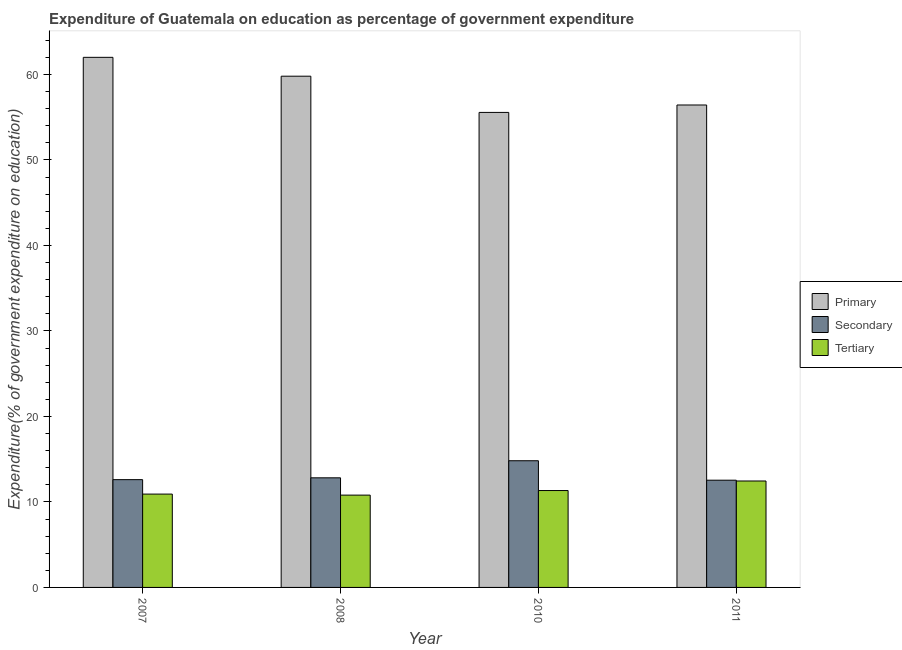How many different coloured bars are there?
Make the answer very short. 3. How many groups of bars are there?
Your answer should be compact. 4. How many bars are there on the 2nd tick from the right?
Keep it short and to the point. 3. What is the label of the 2nd group of bars from the left?
Your answer should be compact. 2008. In how many cases, is the number of bars for a given year not equal to the number of legend labels?
Your response must be concise. 0. What is the expenditure on secondary education in 2011?
Make the answer very short. 12.54. Across all years, what is the maximum expenditure on secondary education?
Give a very brief answer. 14.82. Across all years, what is the minimum expenditure on secondary education?
Offer a terse response. 12.54. In which year was the expenditure on secondary education minimum?
Your response must be concise. 2011. What is the total expenditure on primary education in the graph?
Ensure brevity in your answer.  233.76. What is the difference between the expenditure on tertiary education in 2008 and that in 2010?
Give a very brief answer. -0.54. What is the difference between the expenditure on secondary education in 2011 and the expenditure on tertiary education in 2008?
Offer a terse response. -0.28. What is the average expenditure on secondary education per year?
Make the answer very short. 13.2. What is the ratio of the expenditure on secondary education in 2007 to that in 2008?
Your answer should be very brief. 0.98. Is the expenditure on primary education in 2007 less than that in 2008?
Offer a terse response. No. Is the difference between the expenditure on primary education in 2007 and 2008 greater than the difference between the expenditure on tertiary education in 2007 and 2008?
Offer a very short reply. No. What is the difference between the highest and the second highest expenditure on primary education?
Ensure brevity in your answer.  2.21. What is the difference between the highest and the lowest expenditure on tertiary education?
Ensure brevity in your answer.  1.65. In how many years, is the expenditure on primary education greater than the average expenditure on primary education taken over all years?
Ensure brevity in your answer.  2. Is the sum of the expenditure on primary education in 2008 and 2011 greater than the maximum expenditure on secondary education across all years?
Provide a succinct answer. Yes. What does the 1st bar from the left in 2010 represents?
Your answer should be very brief. Primary. What does the 1st bar from the right in 2011 represents?
Provide a short and direct response. Tertiary. How many years are there in the graph?
Your answer should be compact. 4. What is the difference between two consecutive major ticks on the Y-axis?
Provide a succinct answer. 10. Does the graph contain grids?
Your answer should be very brief. No. What is the title of the graph?
Keep it short and to the point. Expenditure of Guatemala on education as percentage of government expenditure. Does "ICT services" appear as one of the legend labels in the graph?
Your answer should be compact. No. What is the label or title of the X-axis?
Ensure brevity in your answer.  Year. What is the label or title of the Y-axis?
Offer a very short reply. Expenditure(% of government expenditure on education). What is the Expenditure(% of government expenditure on education) of Primary in 2007?
Provide a short and direct response. 62. What is the Expenditure(% of government expenditure on education) in Secondary in 2007?
Ensure brevity in your answer.  12.6. What is the Expenditure(% of government expenditure on education) in Tertiary in 2007?
Offer a terse response. 10.92. What is the Expenditure(% of government expenditure on education) in Primary in 2008?
Give a very brief answer. 59.79. What is the Expenditure(% of government expenditure on education) of Secondary in 2008?
Ensure brevity in your answer.  12.82. What is the Expenditure(% of government expenditure on education) of Tertiary in 2008?
Give a very brief answer. 10.8. What is the Expenditure(% of government expenditure on education) in Primary in 2010?
Provide a succinct answer. 55.55. What is the Expenditure(% of government expenditure on education) of Secondary in 2010?
Provide a short and direct response. 14.82. What is the Expenditure(% of government expenditure on education) of Tertiary in 2010?
Your answer should be compact. 11.33. What is the Expenditure(% of government expenditure on education) of Primary in 2011?
Offer a very short reply. 56.42. What is the Expenditure(% of government expenditure on education) of Secondary in 2011?
Give a very brief answer. 12.54. What is the Expenditure(% of government expenditure on education) of Tertiary in 2011?
Offer a terse response. 12.45. Across all years, what is the maximum Expenditure(% of government expenditure on education) of Primary?
Your answer should be very brief. 62. Across all years, what is the maximum Expenditure(% of government expenditure on education) of Secondary?
Your answer should be compact. 14.82. Across all years, what is the maximum Expenditure(% of government expenditure on education) of Tertiary?
Offer a very short reply. 12.45. Across all years, what is the minimum Expenditure(% of government expenditure on education) in Primary?
Provide a succinct answer. 55.55. Across all years, what is the minimum Expenditure(% of government expenditure on education) in Secondary?
Give a very brief answer. 12.54. Across all years, what is the minimum Expenditure(% of government expenditure on education) in Tertiary?
Your response must be concise. 10.8. What is the total Expenditure(% of government expenditure on education) of Primary in the graph?
Your response must be concise. 233.76. What is the total Expenditure(% of government expenditure on education) of Secondary in the graph?
Offer a very short reply. 52.78. What is the total Expenditure(% of government expenditure on education) in Tertiary in the graph?
Ensure brevity in your answer.  45.49. What is the difference between the Expenditure(% of government expenditure on education) in Primary in 2007 and that in 2008?
Ensure brevity in your answer.  2.21. What is the difference between the Expenditure(% of government expenditure on education) of Secondary in 2007 and that in 2008?
Your answer should be compact. -0.21. What is the difference between the Expenditure(% of government expenditure on education) in Tertiary in 2007 and that in 2008?
Offer a very short reply. 0.12. What is the difference between the Expenditure(% of government expenditure on education) of Primary in 2007 and that in 2010?
Offer a very short reply. 6.44. What is the difference between the Expenditure(% of government expenditure on education) in Secondary in 2007 and that in 2010?
Provide a succinct answer. -2.21. What is the difference between the Expenditure(% of government expenditure on education) in Tertiary in 2007 and that in 2010?
Give a very brief answer. -0.42. What is the difference between the Expenditure(% of government expenditure on education) in Primary in 2007 and that in 2011?
Make the answer very short. 5.57. What is the difference between the Expenditure(% of government expenditure on education) in Secondary in 2007 and that in 2011?
Your answer should be compact. 0.06. What is the difference between the Expenditure(% of government expenditure on education) in Tertiary in 2007 and that in 2011?
Provide a short and direct response. -1.53. What is the difference between the Expenditure(% of government expenditure on education) in Primary in 2008 and that in 2010?
Offer a terse response. 4.24. What is the difference between the Expenditure(% of government expenditure on education) of Secondary in 2008 and that in 2010?
Provide a succinct answer. -2. What is the difference between the Expenditure(% of government expenditure on education) in Tertiary in 2008 and that in 2010?
Offer a very short reply. -0.54. What is the difference between the Expenditure(% of government expenditure on education) of Primary in 2008 and that in 2011?
Offer a terse response. 3.37. What is the difference between the Expenditure(% of government expenditure on education) of Secondary in 2008 and that in 2011?
Your answer should be compact. 0.28. What is the difference between the Expenditure(% of government expenditure on education) in Tertiary in 2008 and that in 2011?
Offer a terse response. -1.65. What is the difference between the Expenditure(% of government expenditure on education) of Primary in 2010 and that in 2011?
Provide a short and direct response. -0.87. What is the difference between the Expenditure(% of government expenditure on education) in Secondary in 2010 and that in 2011?
Your response must be concise. 2.27. What is the difference between the Expenditure(% of government expenditure on education) of Tertiary in 2010 and that in 2011?
Your response must be concise. -1.12. What is the difference between the Expenditure(% of government expenditure on education) of Primary in 2007 and the Expenditure(% of government expenditure on education) of Secondary in 2008?
Your answer should be compact. 49.18. What is the difference between the Expenditure(% of government expenditure on education) of Primary in 2007 and the Expenditure(% of government expenditure on education) of Tertiary in 2008?
Keep it short and to the point. 51.2. What is the difference between the Expenditure(% of government expenditure on education) of Secondary in 2007 and the Expenditure(% of government expenditure on education) of Tertiary in 2008?
Make the answer very short. 1.81. What is the difference between the Expenditure(% of government expenditure on education) in Primary in 2007 and the Expenditure(% of government expenditure on education) in Secondary in 2010?
Keep it short and to the point. 47.18. What is the difference between the Expenditure(% of government expenditure on education) in Primary in 2007 and the Expenditure(% of government expenditure on education) in Tertiary in 2010?
Provide a succinct answer. 50.66. What is the difference between the Expenditure(% of government expenditure on education) of Secondary in 2007 and the Expenditure(% of government expenditure on education) of Tertiary in 2010?
Your answer should be compact. 1.27. What is the difference between the Expenditure(% of government expenditure on education) in Primary in 2007 and the Expenditure(% of government expenditure on education) in Secondary in 2011?
Your answer should be compact. 49.45. What is the difference between the Expenditure(% of government expenditure on education) of Primary in 2007 and the Expenditure(% of government expenditure on education) of Tertiary in 2011?
Provide a succinct answer. 49.55. What is the difference between the Expenditure(% of government expenditure on education) of Secondary in 2007 and the Expenditure(% of government expenditure on education) of Tertiary in 2011?
Your answer should be very brief. 0.16. What is the difference between the Expenditure(% of government expenditure on education) in Primary in 2008 and the Expenditure(% of government expenditure on education) in Secondary in 2010?
Make the answer very short. 44.97. What is the difference between the Expenditure(% of government expenditure on education) in Primary in 2008 and the Expenditure(% of government expenditure on education) in Tertiary in 2010?
Keep it short and to the point. 48.46. What is the difference between the Expenditure(% of government expenditure on education) in Secondary in 2008 and the Expenditure(% of government expenditure on education) in Tertiary in 2010?
Give a very brief answer. 1.49. What is the difference between the Expenditure(% of government expenditure on education) in Primary in 2008 and the Expenditure(% of government expenditure on education) in Secondary in 2011?
Provide a succinct answer. 47.25. What is the difference between the Expenditure(% of government expenditure on education) in Primary in 2008 and the Expenditure(% of government expenditure on education) in Tertiary in 2011?
Offer a very short reply. 47.34. What is the difference between the Expenditure(% of government expenditure on education) in Secondary in 2008 and the Expenditure(% of government expenditure on education) in Tertiary in 2011?
Ensure brevity in your answer.  0.37. What is the difference between the Expenditure(% of government expenditure on education) in Primary in 2010 and the Expenditure(% of government expenditure on education) in Secondary in 2011?
Provide a succinct answer. 43.01. What is the difference between the Expenditure(% of government expenditure on education) of Primary in 2010 and the Expenditure(% of government expenditure on education) of Tertiary in 2011?
Ensure brevity in your answer.  43.11. What is the difference between the Expenditure(% of government expenditure on education) of Secondary in 2010 and the Expenditure(% of government expenditure on education) of Tertiary in 2011?
Your response must be concise. 2.37. What is the average Expenditure(% of government expenditure on education) of Primary per year?
Keep it short and to the point. 58.44. What is the average Expenditure(% of government expenditure on education) in Secondary per year?
Ensure brevity in your answer.  13.2. What is the average Expenditure(% of government expenditure on education) of Tertiary per year?
Offer a very short reply. 11.37. In the year 2007, what is the difference between the Expenditure(% of government expenditure on education) in Primary and Expenditure(% of government expenditure on education) in Secondary?
Give a very brief answer. 49.39. In the year 2007, what is the difference between the Expenditure(% of government expenditure on education) in Primary and Expenditure(% of government expenditure on education) in Tertiary?
Provide a short and direct response. 51.08. In the year 2007, what is the difference between the Expenditure(% of government expenditure on education) in Secondary and Expenditure(% of government expenditure on education) in Tertiary?
Offer a terse response. 1.69. In the year 2008, what is the difference between the Expenditure(% of government expenditure on education) in Primary and Expenditure(% of government expenditure on education) in Secondary?
Provide a short and direct response. 46.97. In the year 2008, what is the difference between the Expenditure(% of government expenditure on education) in Primary and Expenditure(% of government expenditure on education) in Tertiary?
Your response must be concise. 48.99. In the year 2008, what is the difference between the Expenditure(% of government expenditure on education) of Secondary and Expenditure(% of government expenditure on education) of Tertiary?
Provide a succinct answer. 2.02. In the year 2010, what is the difference between the Expenditure(% of government expenditure on education) of Primary and Expenditure(% of government expenditure on education) of Secondary?
Offer a very short reply. 40.74. In the year 2010, what is the difference between the Expenditure(% of government expenditure on education) of Primary and Expenditure(% of government expenditure on education) of Tertiary?
Offer a very short reply. 44.22. In the year 2010, what is the difference between the Expenditure(% of government expenditure on education) in Secondary and Expenditure(% of government expenditure on education) in Tertiary?
Offer a terse response. 3.48. In the year 2011, what is the difference between the Expenditure(% of government expenditure on education) of Primary and Expenditure(% of government expenditure on education) of Secondary?
Your answer should be very brief. 43.88. In the year 2011, what is the difference between the Expenditure(% of government expenditure on education) in Primary and Expenditure(% of government expenditure on education) in Tertiary?
Your answer should be very brief. 43.97. In the year 2011, what is the difference between the Expenditure(% of government expenditure on education) in Secondary and Expenditure(% of government expenditure on education) in Tertiary?
Your answer should be compact. 0.09. What is the ratio of the Expenditure(% of government expenditure on education) of Primary in 2007 to that in 2008?
Your answer should be compact. 1.04. What is the ratio of the Expenditure(% of government expenditure on education) of Secondary in 2007 to that in 2008?
Make the answer very short. 0.98. What is the ratio of the Expenditure(% of government expenditure on education) of Tertiary in 2007 to that in 2008?
Give a very brief answer. 1.01. What is the ratio of the Expenditure(% of government expenditure on education) of Primary in 2007 to that in 2010?
Offer a very short reply. 1.12. What is the ratio of the Expenditure(% of government expenditure on education) in Secondary in 2007 to that in 2010?
Your answer should be compact. 0.85. What is the ratio of the Expenditure(% of government expenditure on education) of Tertiary in 2007 to that in 2010?
Give a very brief answer. 0.96. What is the ratio of the Expenditure(% of government expenditure on education) in Primary in 2007 to that in 2011?
Offer a terse response. 1.1. What is the ratio of the Expenditure(% of government expenditure on education) in Tertiary in 2007 to that in 2011?
Provide a succinct answer. 0.88. What is the ratio of the Expenditure(% of government expenditure on education) in Primary in 2008 to that in 2010?
Provide a short and direct response. 1.08. What is the ratio of the Expenditure(% of government expenditure on education) of Secondary in 2008 to that in 2010?
Offer a terse response. 0.87. What is the ratio of the Expenditure(% of government expenditure on education) of Tertiary in 2008 to that in 2010?
Offer a very short reply. 0.95. What is the ratio of the Expenditure(% of government expenditure on education) in Primary in 2008 to that in 2011?
Ensure brevity in your answer.  1.06. What is the ratio of the Expenditure(% of government expenditure on education) of Secondary in 2008 to that in 2011?
Your answer should be compact. 1.02. What is the ratio of the Expenditure(% of government expenditure on education) in Tertiary in 2008 to that in 2011?
Your answer should be compact. 0.87. What is the ratio of the Expenditure(% of government expenditure on education) in Primary in 2010 to that in 2011?
Offer a very short reply. 0.98. What is the ratio of the Expenditure(% of government expenditure on education) in Secondary in 2010 to that in 2011?
Your answer should be very brief. 1.18. What is the ratio of the Expenditure(% of government expenditure on education) in Tertiary in 2010 to that in 2011?
Provide a succinct answer. 0.91. What is the difference between the highest and the second highest Expenditure(% of government expenditure on education) of Primary?
Keep it short and to the point. 2.21. What is the difference between the highest and the second highest Expenditure(% of government expenditure on education) in Secondary?
Offer a terse response. 2. What is the difference between the highest and the second highest Expenditure(% of government expenditure on education) in Tertiary?
Give a very brief answer. 1.12. What is the difference between the highest and the lowest Expenditure(% of government expenditure on education) in Primary?
Keep it short and to the point. 6.44. What is the difference between the highest and the lowest Expenditure(% of government expenditure on education) of Secondary?
Your response must be concise. 2.27. What is the difference between the highest and the lowest Expenditure(% of government expenditure on education) of Tertiary?
Offer a very short reply. 1.65. 